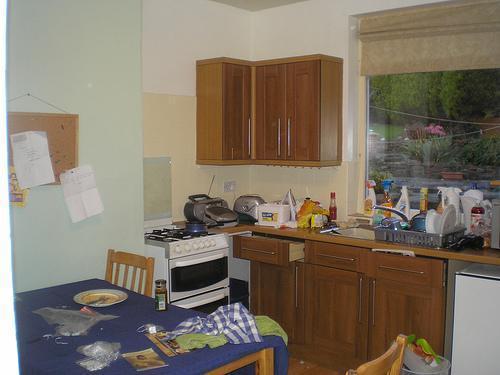How many plates are on the table?
Give a very brief answer. 1. 